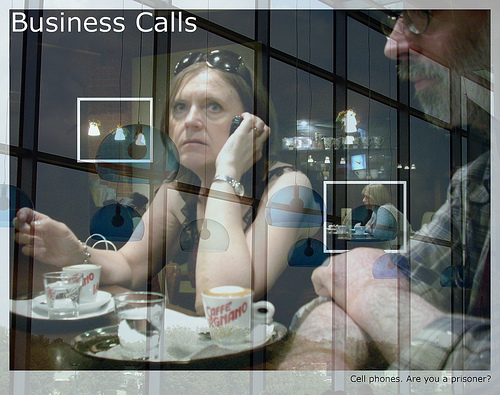Who is talking on the phone? The woman is talking on the phone. 